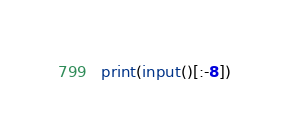Convert code to text. <code><loc_0><loc_0><loc_500><loc_500><_Python_>print(input()[:-8])</code> 